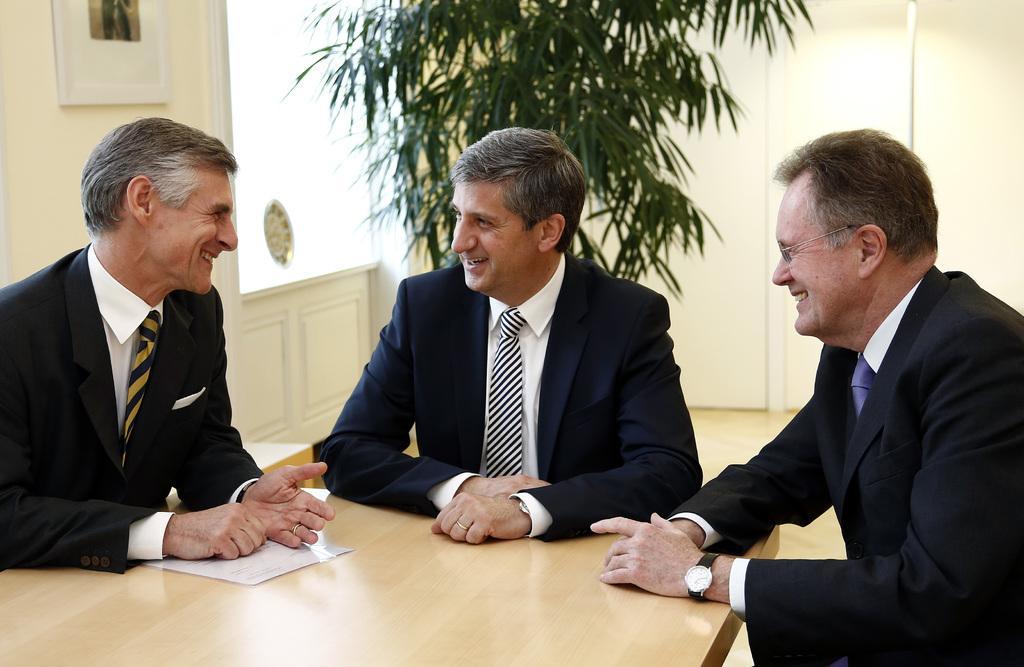Can you describe this image briefly? In front of the image there are three people sitting on the chairs and they are having a smile on their faces. In front of them there is a table. On top of it there is a paper. Behind them there is a flower pot. On the left side of the image there is a photo frame on the wall. There is a glass window. In the background of the image there is a wall. 